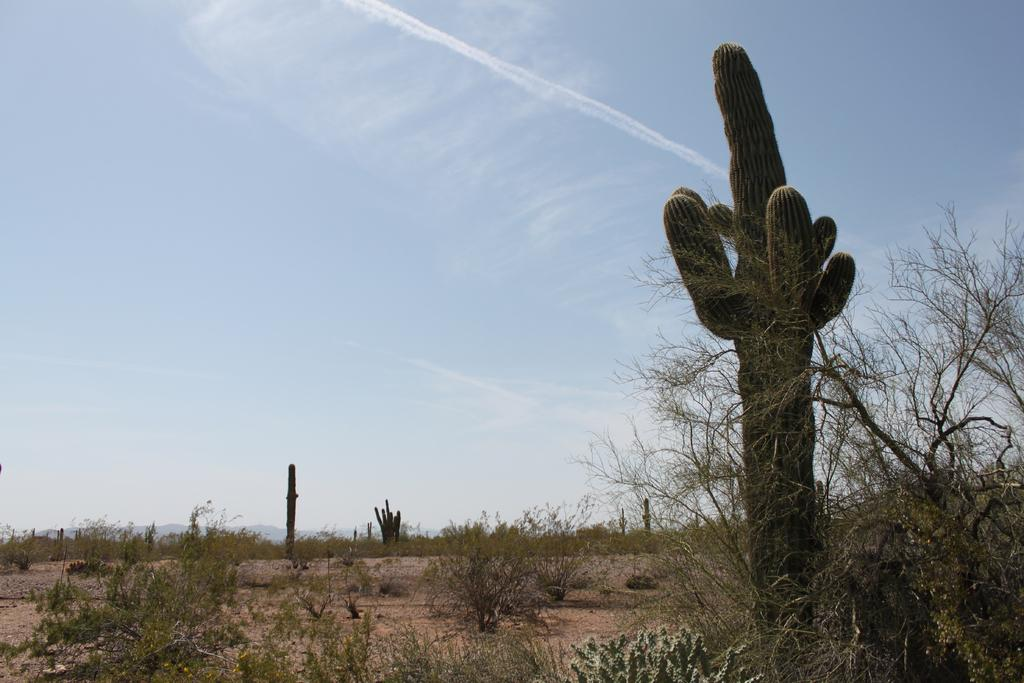What celestial bodies are depicted on the land in the image? There are planets depicted on the land in the image. What can be seen in the background of the image? The sky is visible in the background of the image. What type of town can be seen in the image? There is no town present in the image; it features planets on the land. How many women are visible in the image? There are no women present in the image. 